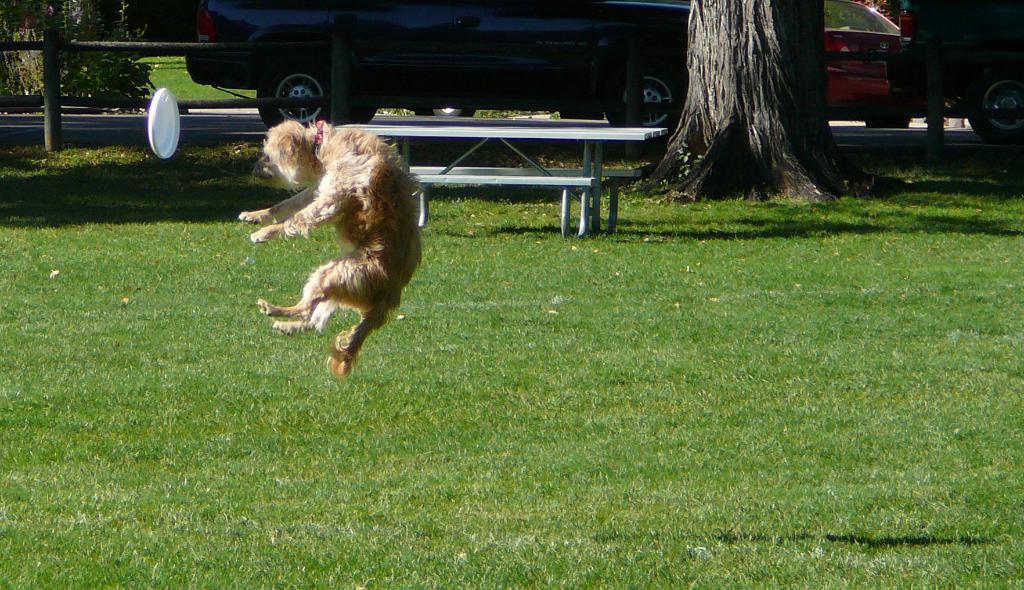Describe this image in one or two sentences. In the middle of the picture, we see a dog which is jumping. In front of it, we see a frisbee disc. I think the dog is playing frisbee. At the bottom of the picture, we see the grass. Beside the dog, we see a bench and behind that we see the stem of the tree. There are vehicles moving on the road. We see iron rods and trees in the background. 